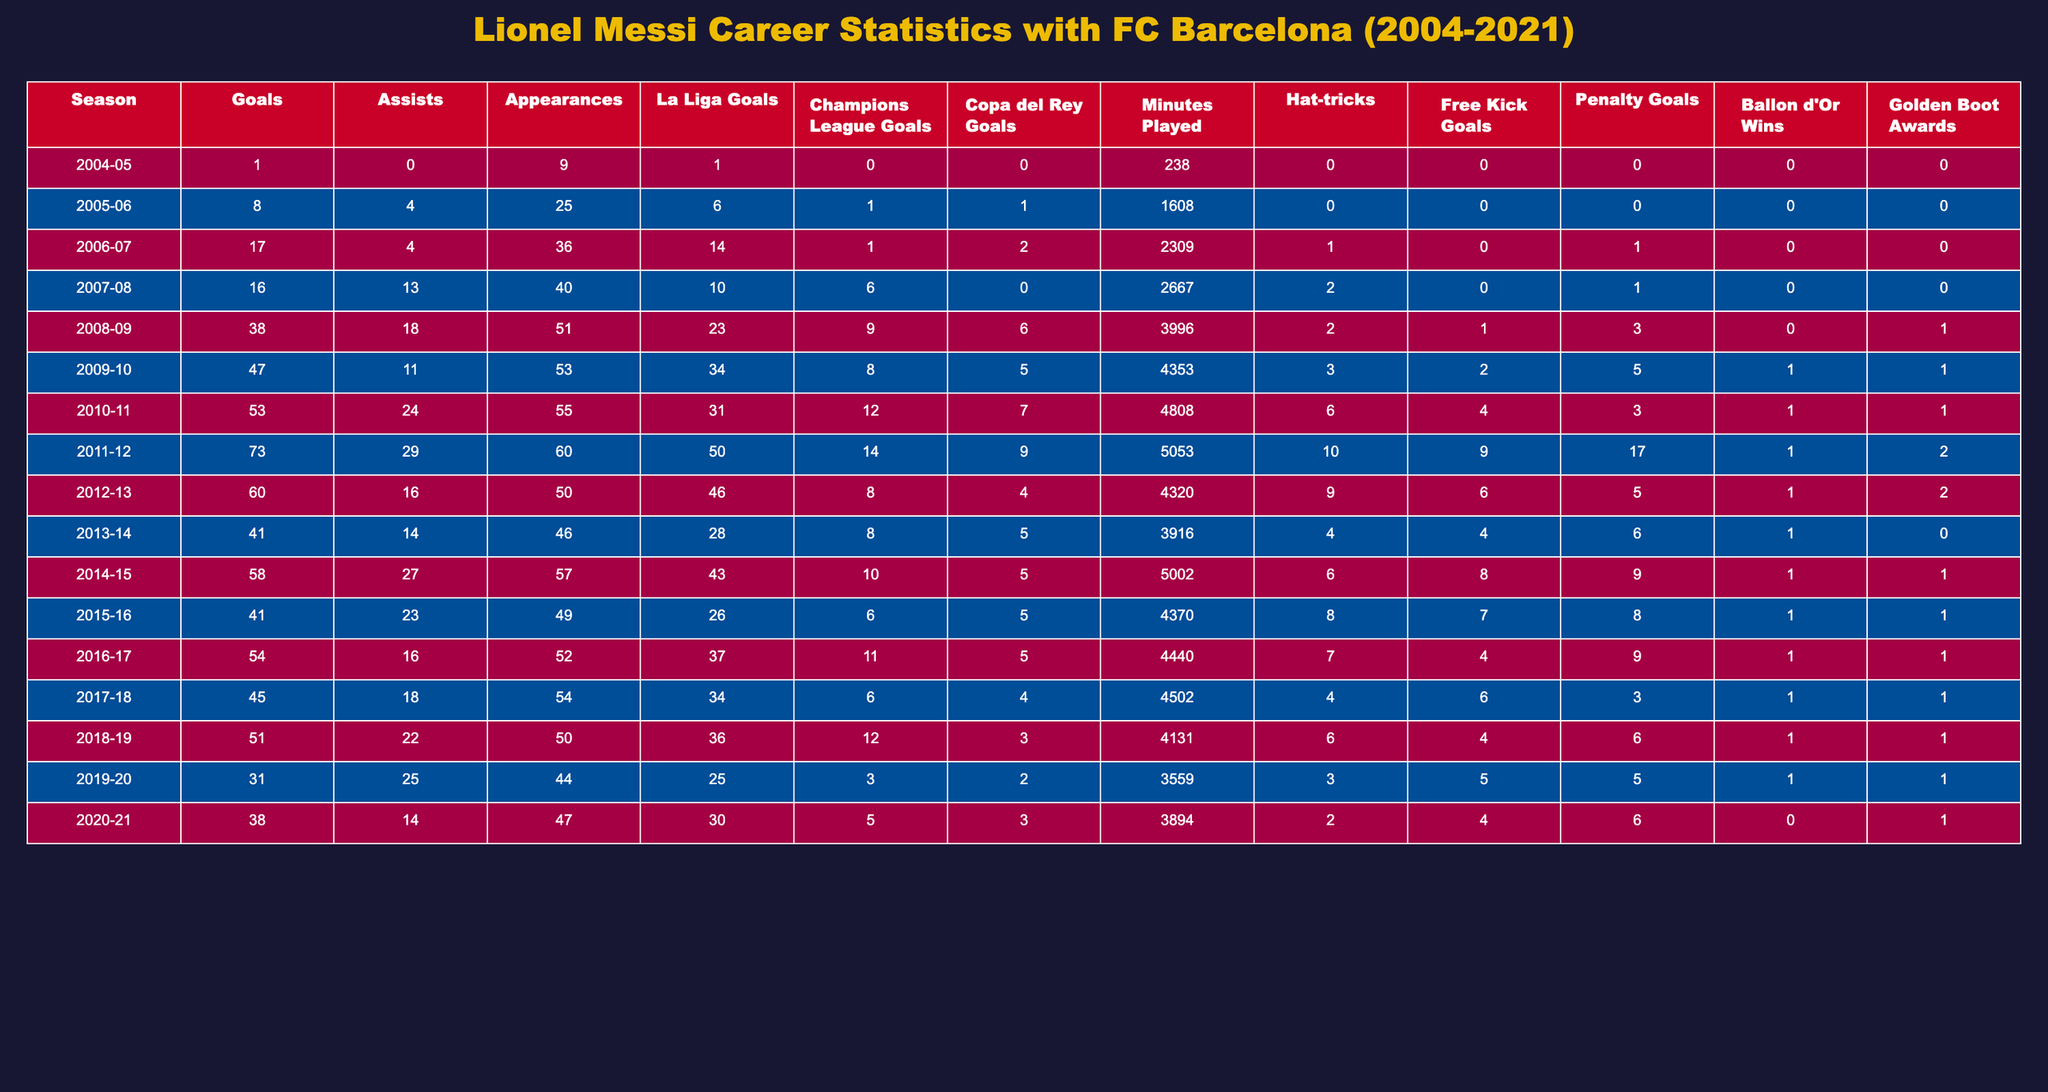What was Lionel Messi's highest number of goals in a single season with FC Barcelona? The highest number of goals scored by Messi in a single season is 73, which occurred in the 2011-12 season.
Answer: 73 How many assists did Messi provide in the 2014-15 season? Messi provided 27 assists in the 2014-15 season, as indicated in the table.
Answer: 27 In how many seasons did Messi score 50 or more goals? Messi scored 50 or more goals in 5 seasons: 2008-09, 2009-10, 2010-11, 2011-12, and 2012-13.
Answer: 5 What was Messi's total number of La Liga goals scored from 2004 to 2021? Summing up the La Liga goals from each season, we have: 1 + 6 + 14 + 10 + 23 + 34 + 31 + 50 + 46 + 28 + 43 + 26 + 37 + 34 + 36 + 25 + 30 = 474. Therefore, Messi scored a total of 474 La Liga goals.
Answer: 474 Did Messi win more Ballon d'Or awards than Golden Boot awards? Messi won 7 Ballon d'Or awards (counting each season where he won) and 1 Golden Boot award, so yes, he won more Ballon d'Or awards.
Answer: Yes Which season had the most hat-tricks scored by Messi? The season with the most hat-tricks scored by Messi was 2011-12, where he recorded 10 hat-tricks.
Answer: 10 What was the average number of goals Messi scored per season from 2004 to 2021? To calculate the average, we sum Messi's total goals (total of 672 from all seasons) and divide by the number of seasons (17), giving us an average of approximately 39.5 goals per season.
Answer: 39.5 Was there a season where Messi scored more than 30 goals and also recorded more than 20 assists? Yes, in the 2015-16 season, Messi scored 41 goals and provided 23 assists, meeting both criteria.
Answer: Yes 